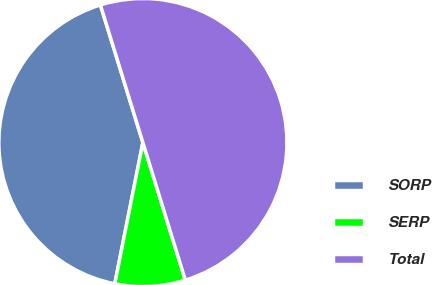Convert chart. <chart><loc_0><loc_0><loc_500><loc_500><pie_chart><fcel>SORP<fcel>SERP<fcel>Total<nl><fcel>42.11%<fcel>7.89%<fcel>50.0%<nl></chart> 